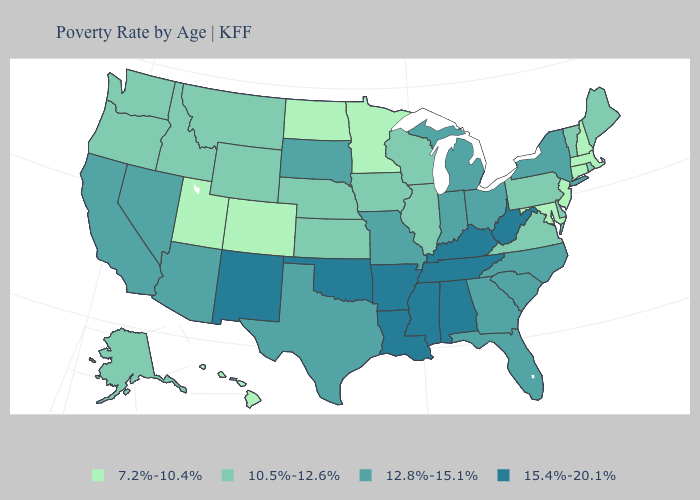Is the legend a continuous bar?
Write a very short answer. No. Name the states that have a value in the range 7.2%-10.4%?
Give a very brief answer. Colorado, Connecticut, Hawaii, Maryland, Massachusetts, Minnesota, New Hampshire, New Jersey, North Dakota, Utah. Name the states that have a value in the range 10.5%-12.6%?
Write a very short answer. Alaska, Delaware, Idaho, Illinois, Iowa, Kansas, Maine, Montana, Nebraska, Oregon, Pennsylvania, Rhode Island, Vermont, Virginia, Washington, Wisconsin, Wyoming. Among the states that border New York , which have the lowest value?
Write a very short answer. Connecticut, Massachusetts, New Jersey. Among the states that border Oregon , does Washington have the highest value?
Short answer required. No. What is the value of Idaho?
Give a very brief answer. 10.5%-12.6%. Does Virginia have a higher value than Colorado?
Quick response, please. Yes. Name the states that have a value in the range 15.4%-20.1%?
Quick response, please. Alabama, Arkansas, Kentucky, Louisiana, Mississippi, New Mexico, Oklahoma, Tennessee, West Virginia. What is the value of Idaho?
Answer briefly. 10.5%-12.6%. What is the highest value in the USA?
Quick response, please. 15.4%-20.1%. What is the lowest value in the West?
Write a very short answer. 7.2%-10.4%. What is the value of Kentucky?
Concise answer only. 15.4%-20.1%. Name the states that have a value in the range 15.4%-20.1%?
Give a very brief answer. Alabama, Arkansas, Kentucky, Louisiana, Mississippi, New Mexico, Oklahoma, Tennessee, West Virginia. Name the states that have a value in the range 10.5%-12.6%?
Concise answer only. Alaska, Delaware, Idaho, Illinois, Iowa, Kansas, Maine, Montana, Nebraska, Oregon, Pennsylvania, Rhode Island, Vermont, Virginia, Washington, Wisconsin, Wyoming. 